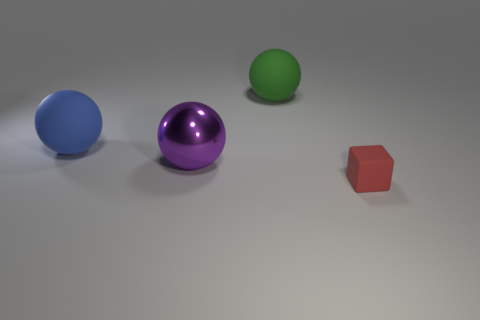Add 2 large green rubber things. How many objects exist? 6 Subtract all cubes. How many objects are left? 3 Subtract all blue spheres. Subtract all green metal spheres. How many objects are left? 3 Add 4 green rubber things. How many green rubber things are left? 5 Add 2 large yellow spheres. How many large yellow spheres exist? 2 Subtract 0 blue blocks. How many objects are left? 4 